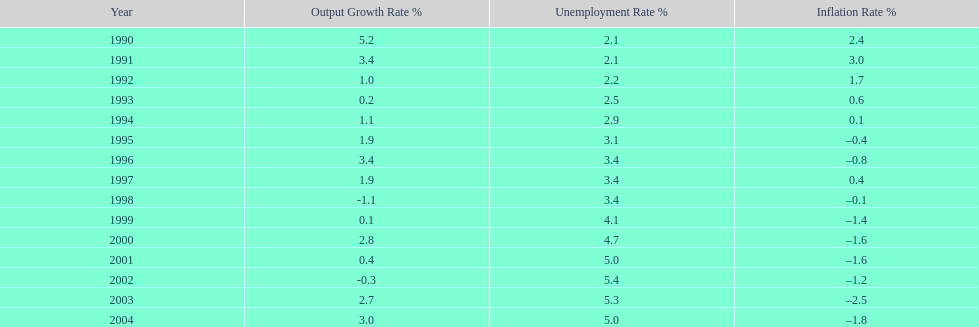During the 1990s, at what point did the inflation rate first drop below zero? 1995. Would you mind parsing the complete table? {'header': ['Year', 'Output Growth Rate\xa0%', 'Unemployment Rate\xa0%', 'Inflation Rate\xa0%'], 'rows': [['1990', '5.2', '2.1', '2.4'], ['1991', '3.4', '2.1', '3.0'], ['1992', '1.0', '2.2', '1.7'], ['1993', '0.2', '2.5', '0.6'], ['1994', '1.1', '2.9', '0.1'], ['1995', '1.9', '3.1', '–0.4'], ['1996', '3.4', '3.4', '–0.8'], ['1997', '1.9', '3.4', '0.4'], ['1998', '-1.1', '3.4', '–0.1'], ['1999', '0.1', '4.1', '–1.4'], ['2000', '2.8', '4.7', '–1.6'], ['2001', '0.4', '5.0', '–1.6'], ['2002', '-0.3', '5.4', '–1.2'], ['2003', '2.7', '5.3', '–2.5'], ['2004', '3.0', '5.0', '–1.8']]} 